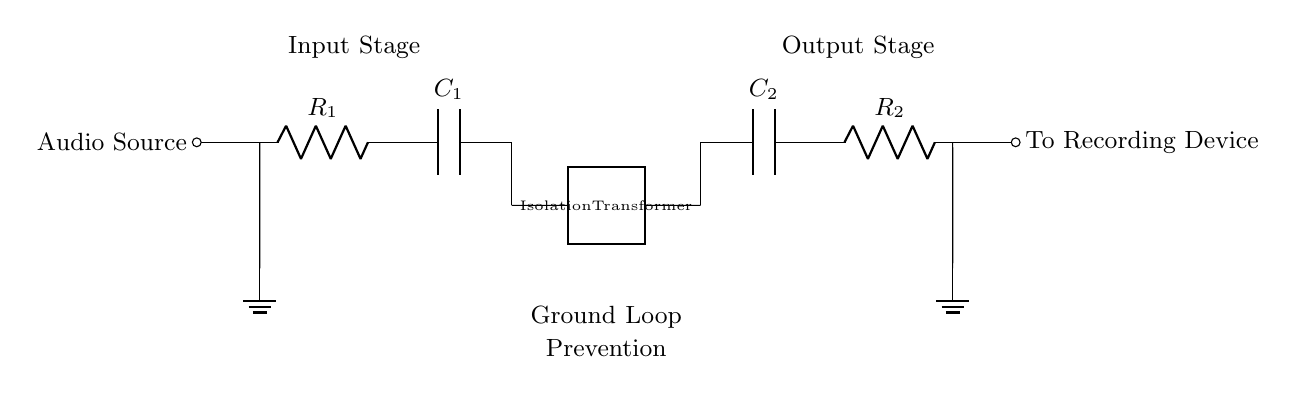What component is used for isolation in this circuit? The circuit includes an isolation transformer, which is specifically designed to separate different parts of the circuit, preventing unwanted interference and ground loops. This is indicated in the circuit diagram labeled as "Isolation Transformer."
Answer: Isolation Transformer What are the two capacitors in the circuit labeled as? The circuit diagram shows two capacitors: C1 at the input stage and C2 at the output stage. These capacitors are represented clearly next to their respective positions in the circuit.
Answer: C1 and C2 What is the purpose of the resistors in the circuit? The resistors, R1 and R2, function as load elements to manage current flow and impedance in both the input and output stages. They help stabilize the circuit for effective audio signal transmission.
Answer: Current management How does the circuit prevent ground loops? The circuit prevents ground loops primarily through the isolation transformer, which breaks the electrical connection that could create a ground loop while allowing audio signals to pass through. This is crucial in reducing noise in the audio signal.
Answer: Isolation transformer What does the label "Ground Loop Prevention" signify in the circuit? "Ground Loop Prevention" indicates the circuit's primary functionality, which is to eliminate the interference caused by ground loops, resulting in enhanced sound quality during podcast recordings. This label specifically communicates the goal of the entire circuit design.
Answer: Elimination of interference 